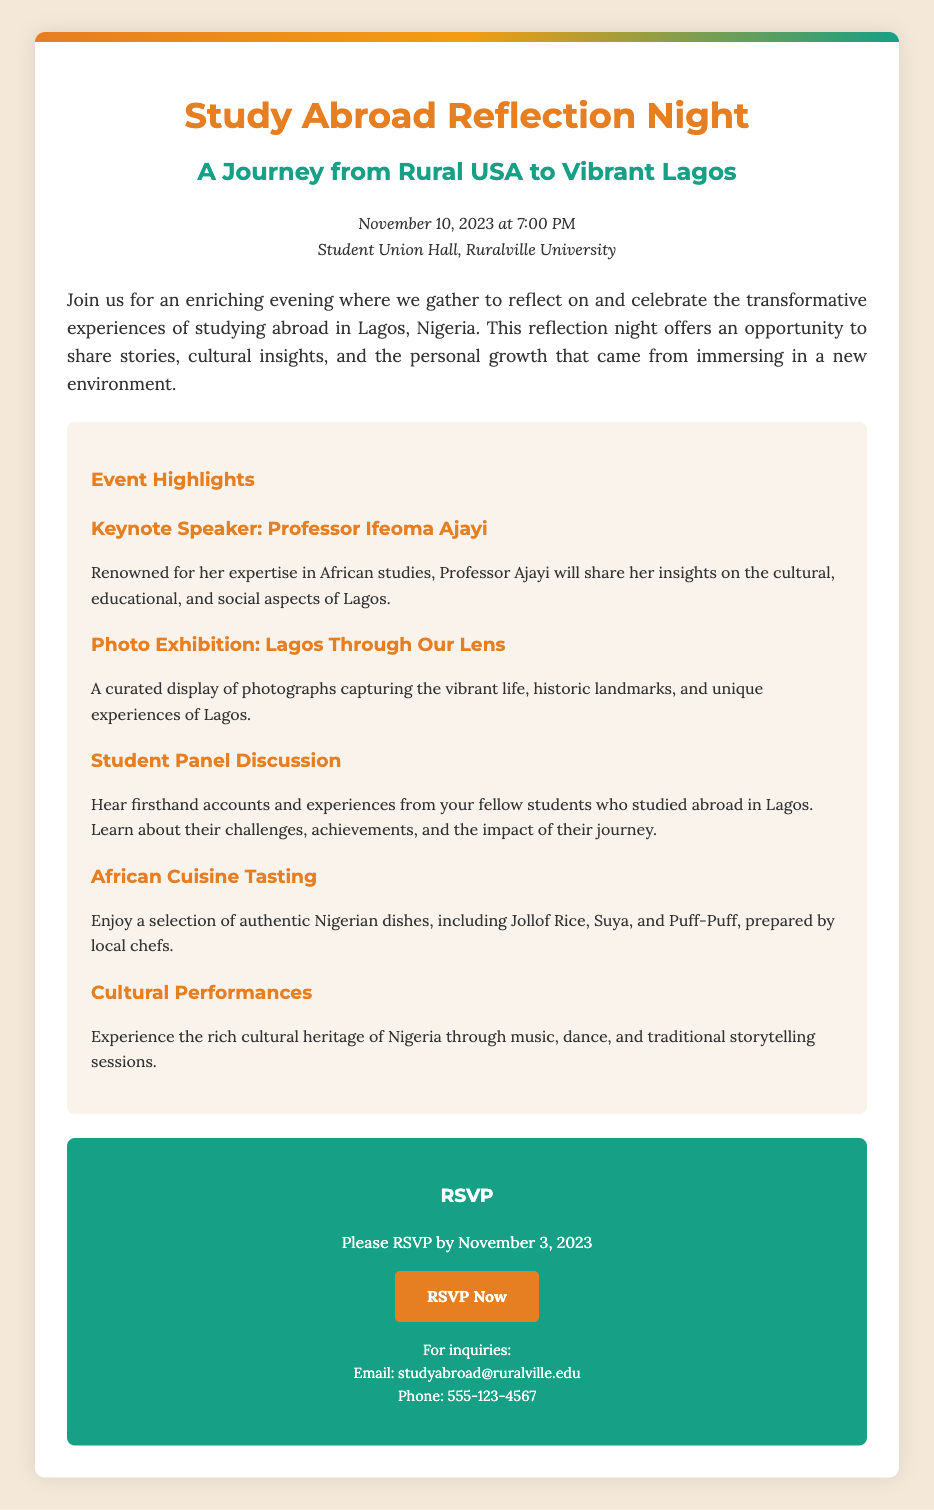What is the date of the event? The event is scheduled to take place on November 10, 2023.
Answer: November 10, 2023 Who is the keynote speaker? The keynote speaker for the event is Professor Ifeoma Ajayi.
Answer: Professor Ifeoma Ajayi What is the venue for the event? The RSVP document mentions that the event will be held at the Student Union Hall, Ruralville University.
Answer: Student Union Hall, Ruralville University By what date should attendees RSVP? Attendees are asked to RSVP by November 3, 2023.
Answer: November 3, 2023 What type of cuisine will be featured at the event? The event will include a tasting of authentic Nigerian dishes.
Answer: Nigerian dishes What is one of the highlights of the event? One of the highlights includes a photo exhibition titled "Lagos Through Our Lens."
Answer: Photo Exhibition: Lagos Through Our Lens What time does the event start? The event is scheduled to start at 7:00 PM.
Answer: 7:00 PM What email should inquiries be sent to? Inquiries should be sent to studyabroad@ruralville.edu.
Answer: studyabroad@ruralville.edu 